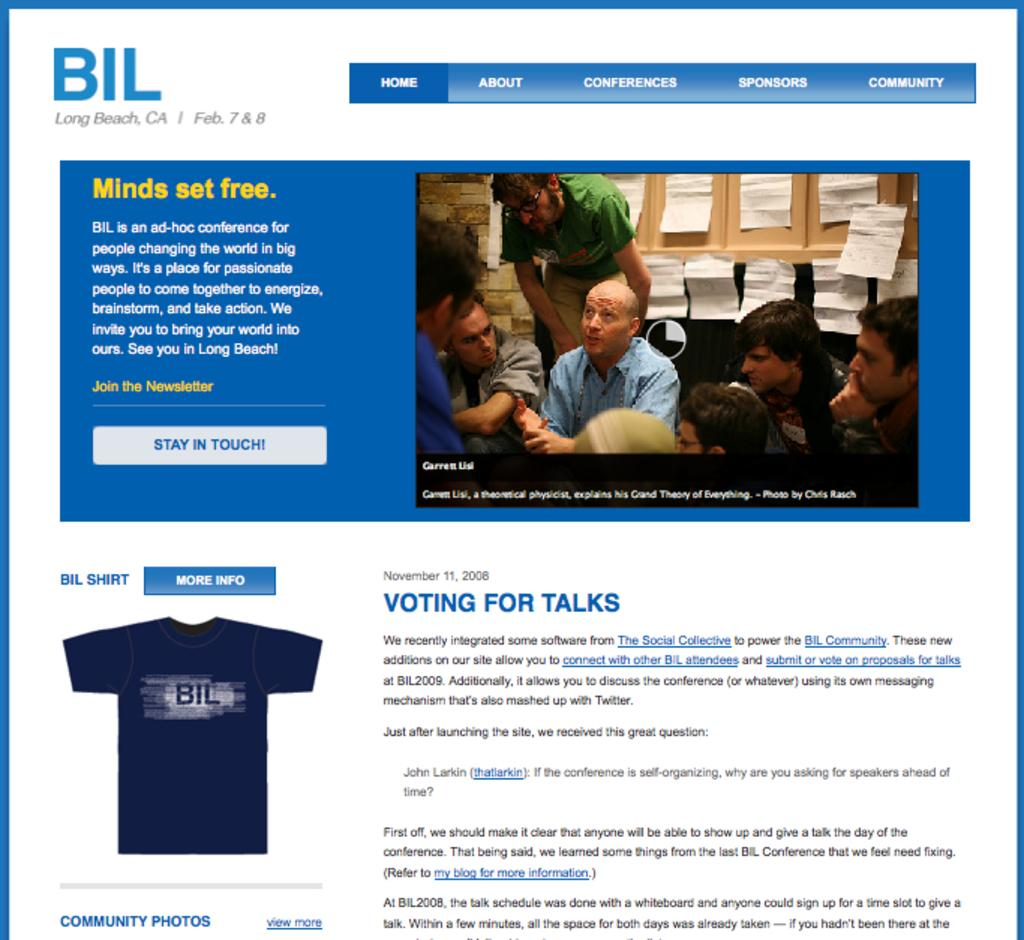What object can be seen in the image that contains information? There is a pamphlet in the image that contains information. What are the people in the image doing? The people in the image are sitting. How can you describe the appearance of the people in the image? The people are wearing different color dresses. What can be found on the pamphlet in the image? There is writing on the pamphlet. What type of record is being played by the people in the image? There is no record or music player present in the image. What is the rake being used for in the image? There is no rake present in the image. 